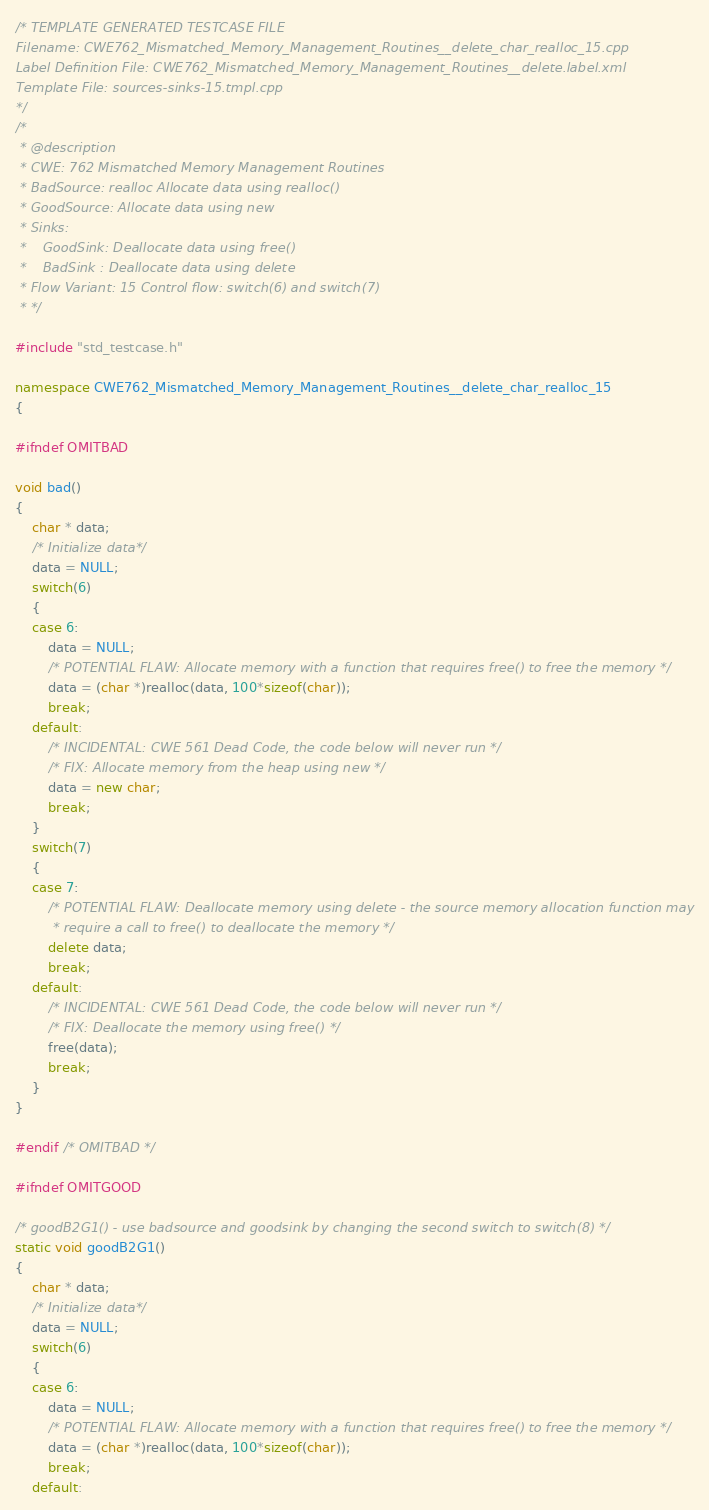Convert code to text. <code><loc_0><loc_0><loc_500><loc_500><_C++_>/* TEMPLATE GENERATED TESTCASE FILE
Filename: CWE762_Mismatched_Memory_Management_Routines__delete_char_realloc_15.cpp
Label Definition File: CWE762_Mismatched_Memory_Management_Routines__delete.label.xml
Template File: sources-sinks-15.tmpl.cpp
*/
/*
 * @description
 * CWE: 762 Mismatched Memory Management Routines
 * BadSource: realloc Allocate data using realloc()
 * GoodSource: Allocate data using new
 * Sinks:
 *    GoodSink: Deallocate data using free()
 *    BadSink : Deallocate data using delete
 * Flow Variant: 15 Control flow: switch(6) and switch(7)
 * */

#include "std_testcase.h"

namespace CWE762_Mismatched_Memory_Management_Routines__delete_char_realloc_15
{

#ifndef OMITBAD

void bad()
{
    char * data;
    /* Initialize data*/
    data = NULL;
    switch(6)
    {
    case 6:
        data = NULL;
        /* POTENTIAL FLAW: Allocate memory with a function that requires free() to free the memory */
        data = (char *)realloc(data, 100*sizeof(char));
        break;
    default:
        /* INCIDENTAL: CWE 561 Dead Code, the code below will never run */
        /* FIX: Allocate memory from the heap using new */
        data = new char;
        break;
    }
    switch(7)
    {
    case 7:
        /* POTENTIAL FLAW: Deallocate memory using delete - the source memory allocation function may
         * require a call to free() to deallocate the memory */
        delete data;
        break;
    default:
        /* INCIDENTAL: CWE 561 Dead Code, the code below will never run */
        /* FIX: Deallocate the memory using free() */
        free(data);
        break;
    }
}

#endif /* OMITBAD */

#ifndef OMITGOOD

/* goodB2G1() - use badsource and goodsink by changing the second switch to switch(8) */
static void goodB2G1()
{
    char * data;
    /* Initialize data*/
    data = NULL;
    switch(6)
    {
    case 6:
        data = NULL;
        /* POTENTIAL FLAW: Allocate memory with a function that requires free() to free the memory */
        data = (char *)realloc(data, 100*sizeof(char));
        break;
    default:</code> 